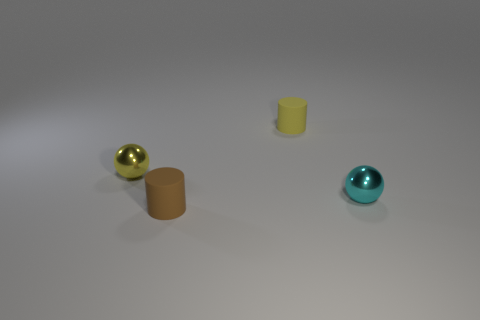Is the shape of the cyan object the same as the yellow metal object?
Your answer should be very brief. Yes. How many small cyan balls are behind the shiny ball that is behind the cyan metal sphere?
Provide a short and direct response. 0. What shape is the yellow thing that is made of the same material as the brown cylinder?
Give a very brief answer. Cylinder. What number of yellow objects are either small metal spheres or tiny cylinders?
Offer a very short reply. 2. There is a tiny yellow object that is to the left of the matte cylinder behind the brown rubber object; are there any tiny things that are behind it?
Provide a succinct answer. Yes. Are there fewer matte cylinders than objects?
Ensure brevity in your answer.  Yes. Do the tiny shiny thing behind the tiny cyan metallic ball and the small brown matte thing have the same shape?
Your answer should be compact. No. Are any green shiny balls visible?
Keep it short and to the point. No. The small metallic thing in front of the small metal object that is left of the shiny thing that is on the right side of the small brown cylinder is what color?
Your answer should be very brief. Cyan. Is the number of yellow objects that are in front of the yellow shiny ball the same as the number of cylinders behind the small cyan shiny thing?
Make the answer very short. No. 